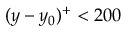<formula> <loc_0><loc_0><loc_500><loc_500>( y - y _ { 0 } ) ^ { + } < 2 0 0</formula> 